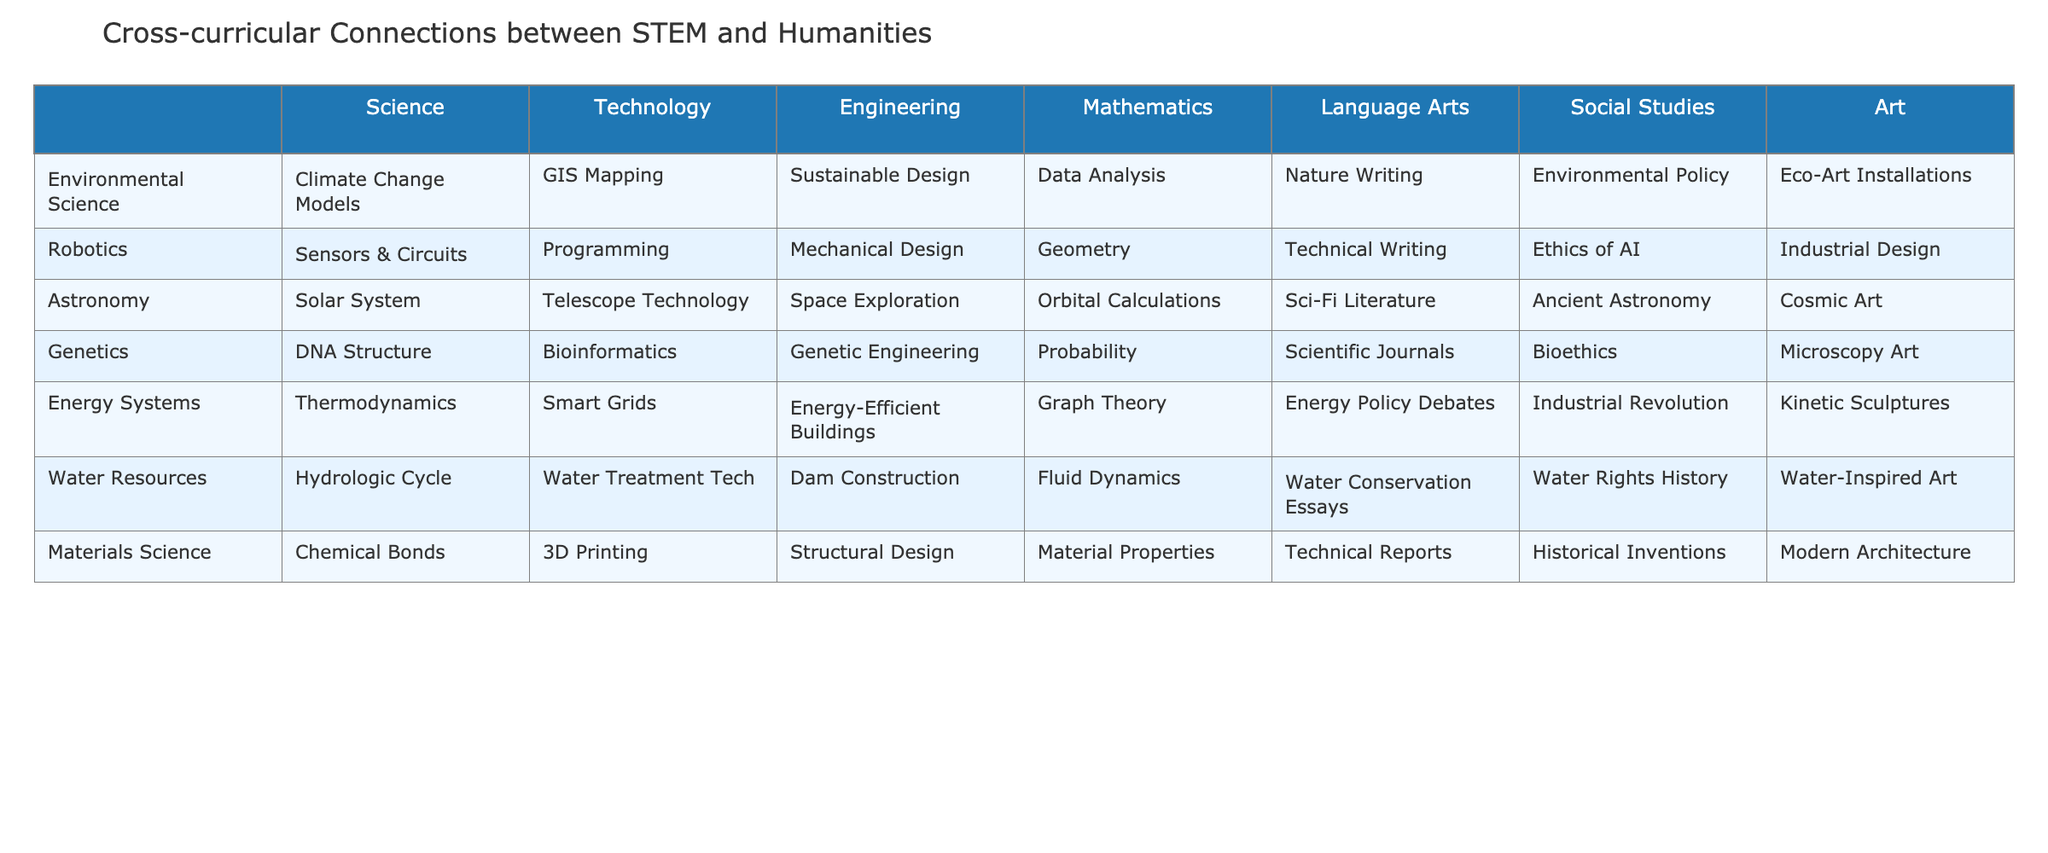What environmental science topic is associated with data analysis? According to the table, the environmental science topic associated with data analysis is "Data Analysis" under the Science column for Environmental Science.
Answer: Data Analysis How many subjects include "Robotics" in their title? The table lists only one subject with "Robotics" in its title, which is "Robotics" itself.
Answer: 1 Which STEM subject has the most connections to language arts? By reviewing the table, both Environmental Science and Robotics have language arts connections, but Environmental Science also has Nature Writing, which showcases a direct link to creativity.
Answer: Environmental Science Are there any subjects that connect technology with the arts? Yes, the table shows that the Engineering subject includes connections to Industrial Design and also includes connections in other areas.
Answer: Yes Which subject contains the topic of "Water Conservation Essays"? The subject that contains "Water Conservation Essays" is "Water Resources," as shown in the table.
Answer: Water Resources What is the connection between genetics and mathematics? The connection between genetics and mathematics is presented as "Probability" in the table under the Mathematics column.
Answer: Probability How many subjects link engineering to art? The table shows that three subjects link engineering to art: Robotics (Industrial Design), Energy Systems (Kinetic Sculptures), and Materials Science (Modern Architecture), making it a total of three subjects.
Answer: 3 In which subject is "Solar System" listed? "Solar System" is listed under the Astronomy subject in the table.
Answer: Astronomy What do the connections between Environmental Science and Social Studies focus on? The connection between Environmental Science and Social Studies focuses on "Environmental Policy," as indicated in the table.
Answer: Environmental Policy What are the connections between technology and mathematics in Energy Systems? The connections between technology and mathematics in Energy Systems are represented as "Smart Grids" and "Graph Theory," respectively, indicating a relationship between energy technology and mathematical modeling.
Answer: Smart Grids, Graph Theory 